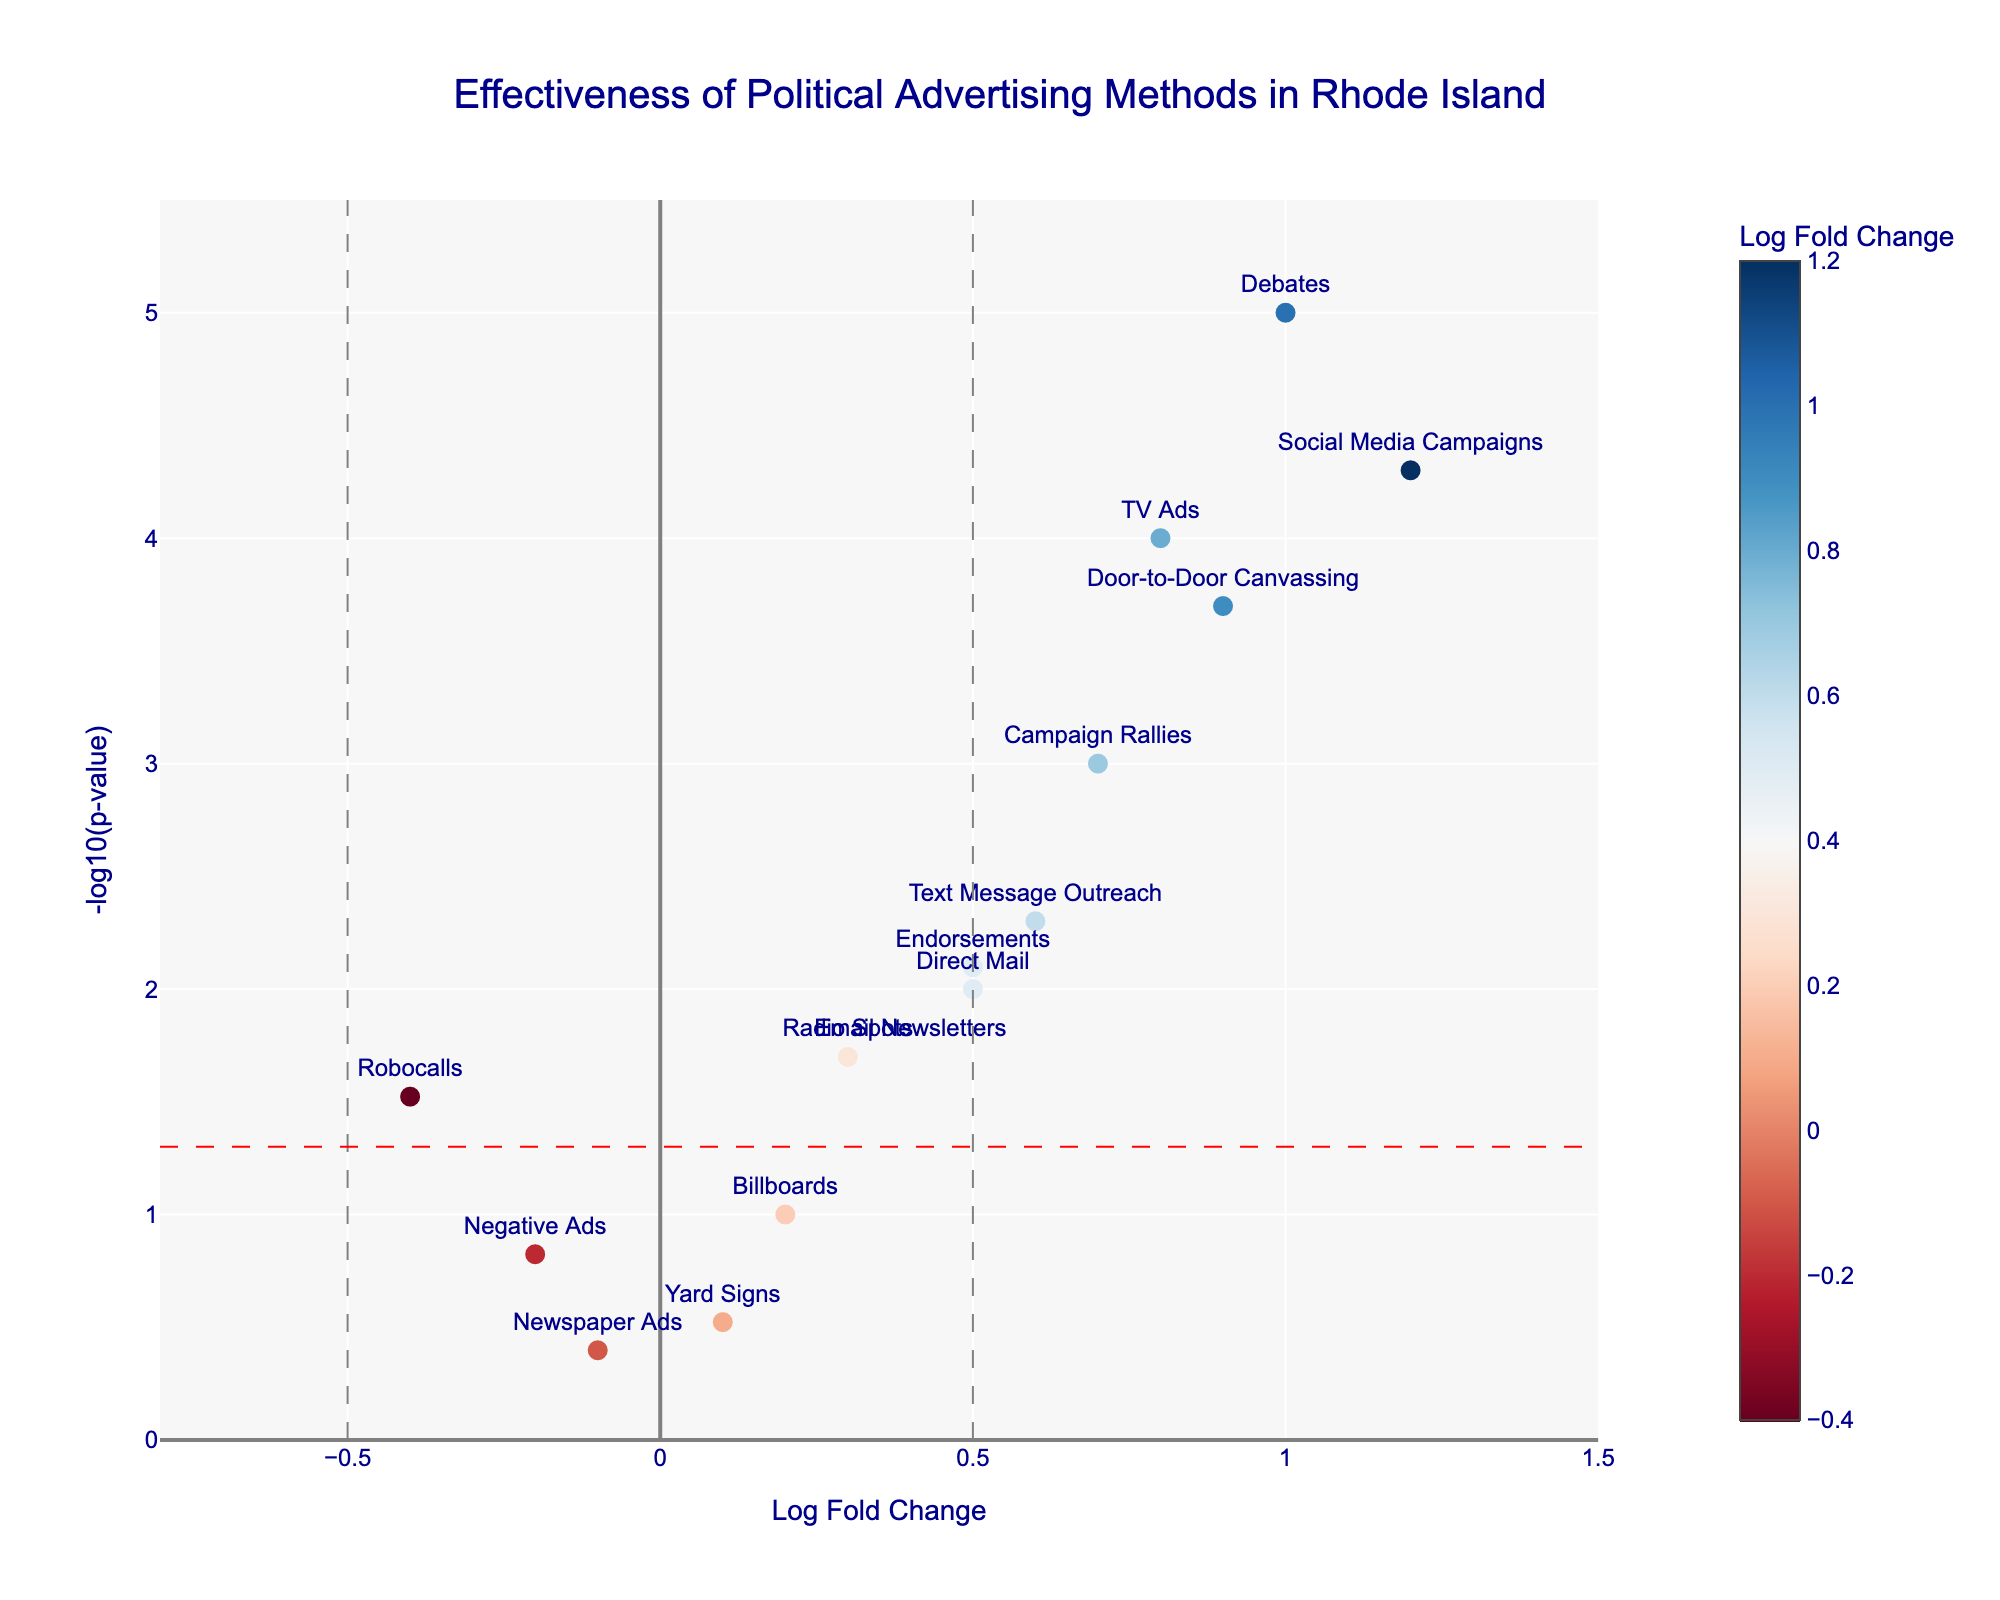What's the title of the figure? The title is located at the top center of the plot.
Answer: Effectiveness of Political Advertising Methods in Rhode Island What is the meaning of the x-axis? The x-axis represents the Log Fold Change of the effectiveness of different political advertising methods on voter behavior.
Answer: Log Fold Change What is the meaning of the y-axis? The y-axis represents the -log10(p-value), indicating statistical significance of the advertising methods' effectiveness.
Answer: -log10(p-value) Which method has the highest impact on voter behavior? Check the data point with the highest Log Fold Change on the x-axis.
Answer: Social Media Campaigns How many methods have a statistically significant p-value below 0.05? Look for methods above the red horizontal line on the plot, which represents a p-value threshold of 0.05.
Answer: 8 methods Which method is associated with reduced voter behavior (negative impact) but is statistically significant? Identify the methods with a negative Log Fold Change (to the left of the y-axis) and above the red horizontal line.
Answer: Robocalls What is the Log Fold Change and p-value for TV Ads? Refer to the hover text on the data point labeled "TV Ads" or the plotted data.
Answer: Log Fold Change: 0.8, p-value: 0.0001 Among the methods that are not statistically significant, which one has the highest impact on voter behavior? Determine which data point is closest to the top but below the red line, to the right of the y-axis.
Answer: Billboards Compare the statistical significance of Door-to-Door Canvassing and Text Message Outreach. Which one is more statistically significant? Compare the -log10(p-value) values for both methods, the higher the value, the more statistically significant.
Answer: Door-to-Door Canvassing Which method has a Log Fold Change less than 0 and is not statistically significant? Identify the data points with a negative Log Fold Change (left of the y-axis) and below the red horizontal line.
Answer: Negative Ads 